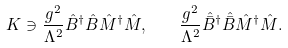Convert formula to latex. <formula><loc_0><loc_0><loc_500><loc_500>K \ni \frac { g ^ { 2 } } { \Lambda ^ { 2 } } \hat { B } ^ { \dagger } \hat { B } \hat { M } ^ { \dagger } \hat { M } , \quad \frac { g ^ { 2 } } { \Lambda ^ { 2 } } \hat { \bar { B } } ^ { \dagger } \hat { \bar { B } } \hat { M } ^ { \dagger } \hat { M } .</formula> 